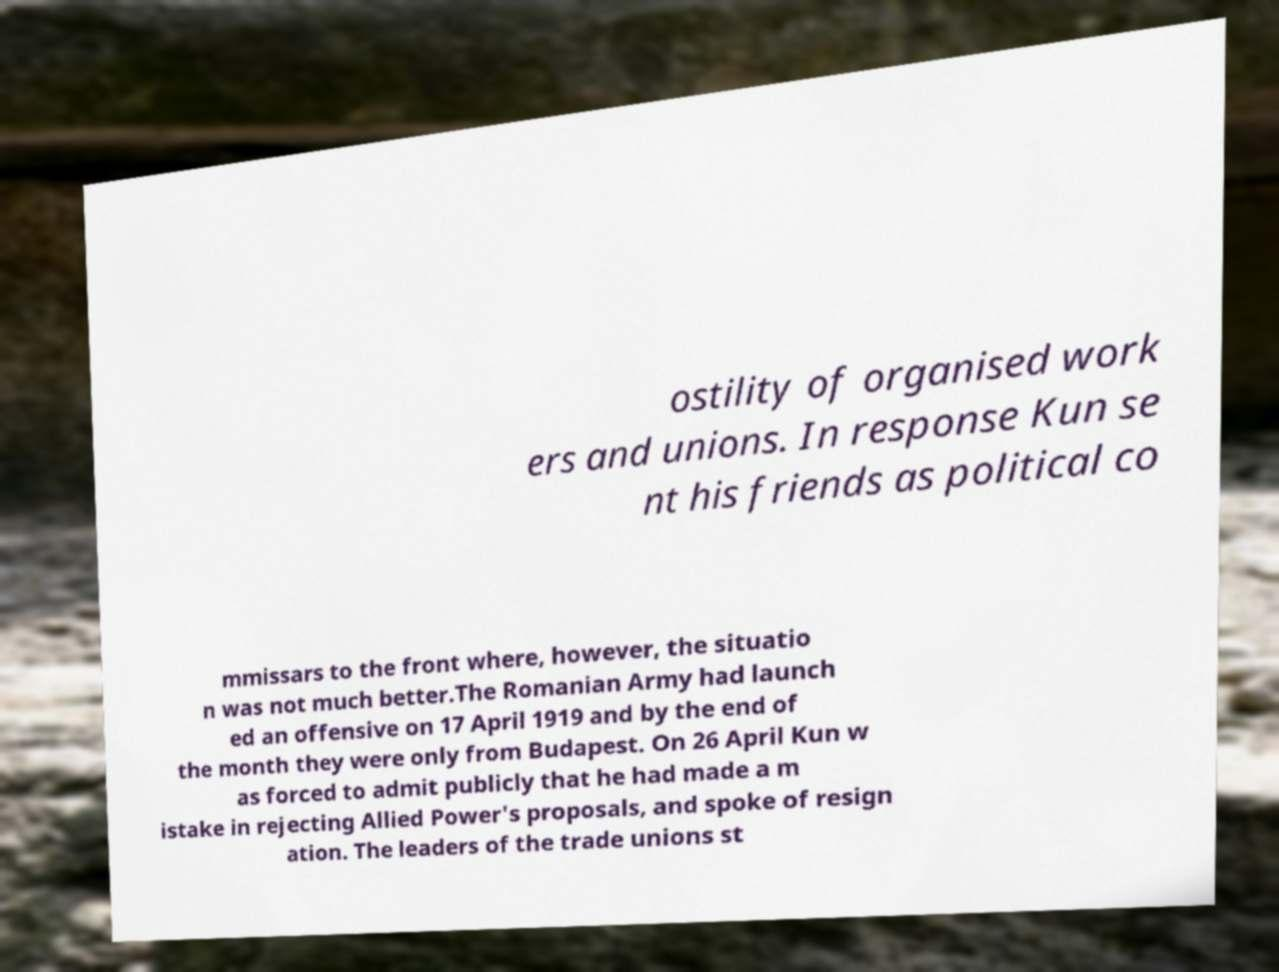There's text embedded in this image that I need extracted. Can you transcribe it verbatim? ostility of organised work ers and unions. In response Kun se nt his friends as political co mmissars to the front where, however, the situatio n was not much better.The Romanian Army had launch ed an offensive on 17 April 1919 and by the end of the month they were only from Budapest. On 26 April Kun w as forced to admit publicly that he had made a m istake in rejecting Allied Power's proposals, and spoke of resign ation. The leaders of the trade unions st 